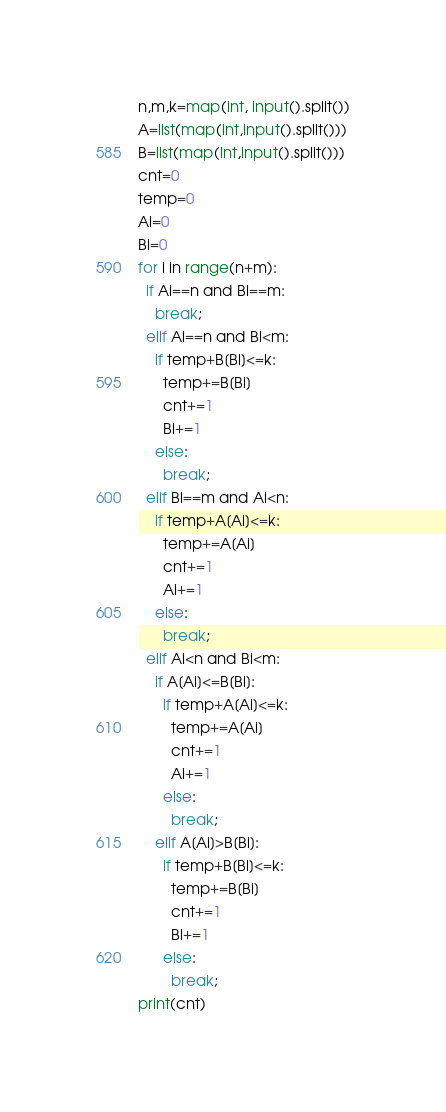<code> <loc_0><loc_0><loc_500><loc_500><_Python_>n,m,k=map(int, input().split())
A=list(map(int,input().split()))
B=list(map(int,input().split()))
cnt=0
temp=0
Ai=0
Bi=0
for i in range(n+m):
  if Ai==n and Bi==m:
    break;
  elif Ai==n and Bi<m:
    if temp+B[Bi]<=k:
      temp+=B[Bi]
      cnt+=1
      Bi+=1
    else:
      break;
  elif Bi==m and Ai<n:
    if temp+A[Ai]<=k:
      temp+=A[Ai]
      cnt+=1
      Ai+=1
    else:
      break;
  elif Ai<n and Bi<m:
    if A[Ai]<=B[Bi]:
      if temp+A[Ai]<=k:
        temp+=A[Ai]
        cnt+=1
        Ai+=1
      else:
        break;
    elif A[Ai]>B[Bi]:
      if temp+B[Bi]<=k:
        temp+=B[Bi]
        cnt+=1
        Bi+=1
      else:
        break;
print(cnt)</code> 